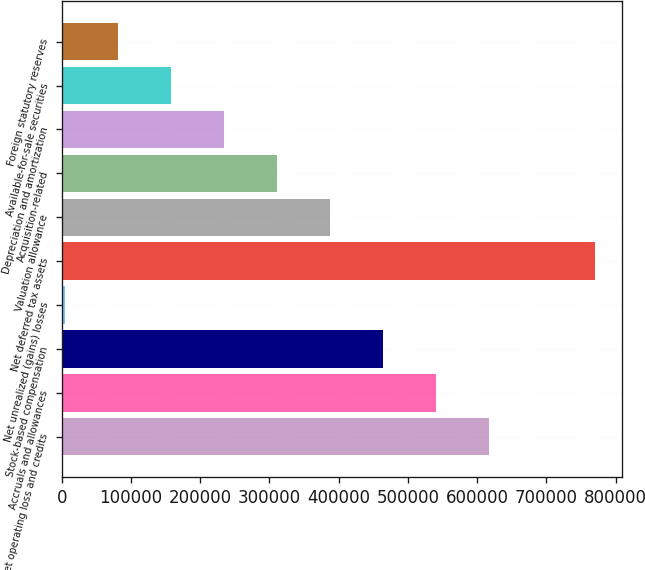Convert chart to OTSL. <chart><loc_0><loc_0><loc_500><loc_500><bar_chart><fcel>Net operating loss and credits<fcel>Accruals and allowances<fcel>Stock-based compensation<fcel>Net unrealized (gains) losses<fcel>Net deferred tax assets<fcel>Valuation allowance<fcel>Acquisition-related<fcel>Depreciation and amortization<fcel>Available-for-sale securities<fcel>Foreign statutory reserves<nl><fcel>617426<fcel>540754<fcel>464082<fcel>4052<fcel>770769<fcel>387410<fcel>310739<fcel>234067<fcel>157395<fcel>80723.7<nl></chart> 